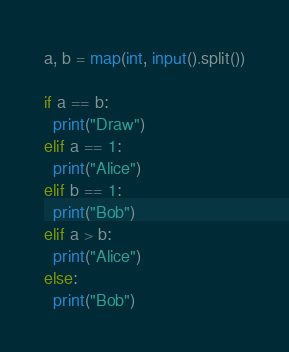Convert code to text. <code><loc_0><loc_0><loc_500><loc_500><_Python_>a, b = map(int, input().split())

if a == b:
  print("Draw")
elif a == 1:
  print("Alice")
elif b == 1:
  print("Bob")
elif a > b:
  print("Alice")
else:
  print("Bob")</code> 